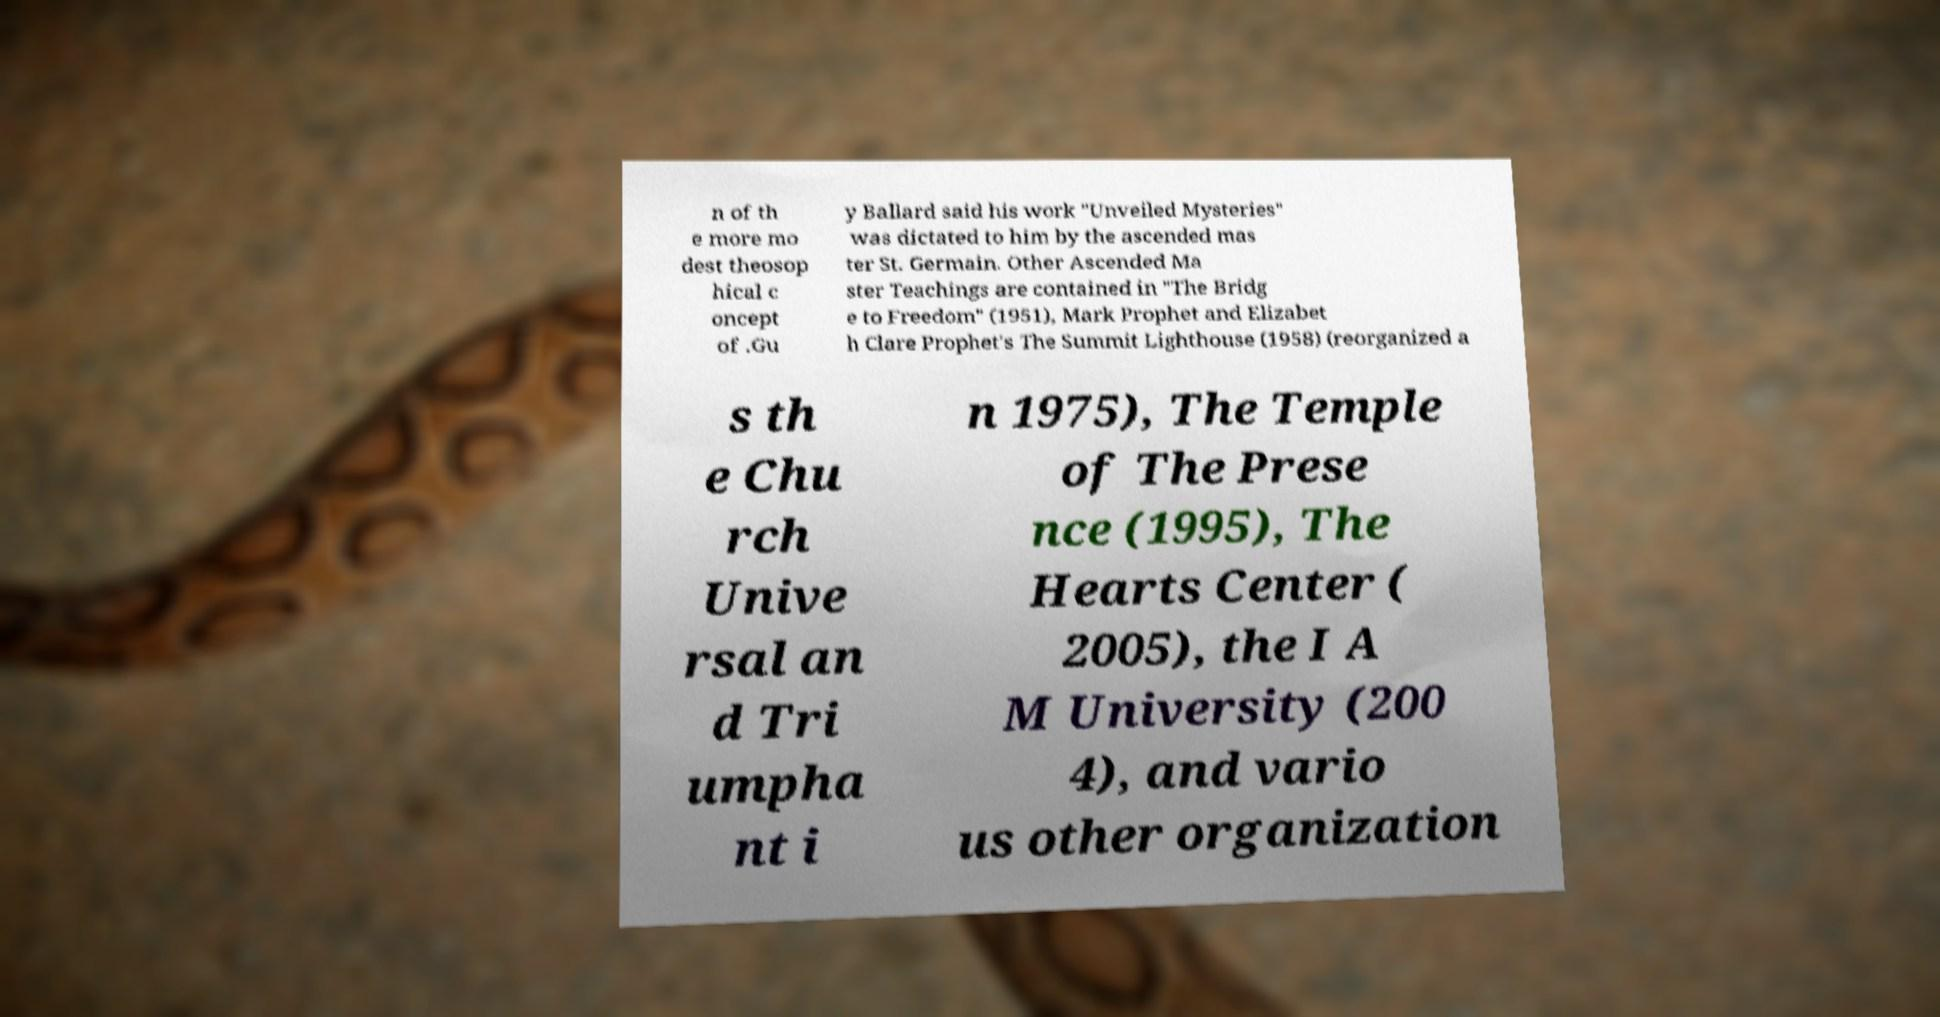Please read and relay the text visible in this image. What does it say? n of th e more mo dest theosop hical c oncept of .Gu y Ballard said his work "Unveiled Mysteries" was dictated to him by the ascended mas ter St. Germain. Other Ascended Ma ster Teachings are contained in "The Bridg e to Freedom" (1951), Mark Prophet and Elizabet h Clare Prophet's The Summit Lighthouse (1958) (reorganized a s th e Chu rch Unive rsal an d Tri umpha nt i n 1975), The Temple of The Prese nce (1995), The Hearts Center ( 2005), the I A M University (200 4), and vario us other organization 